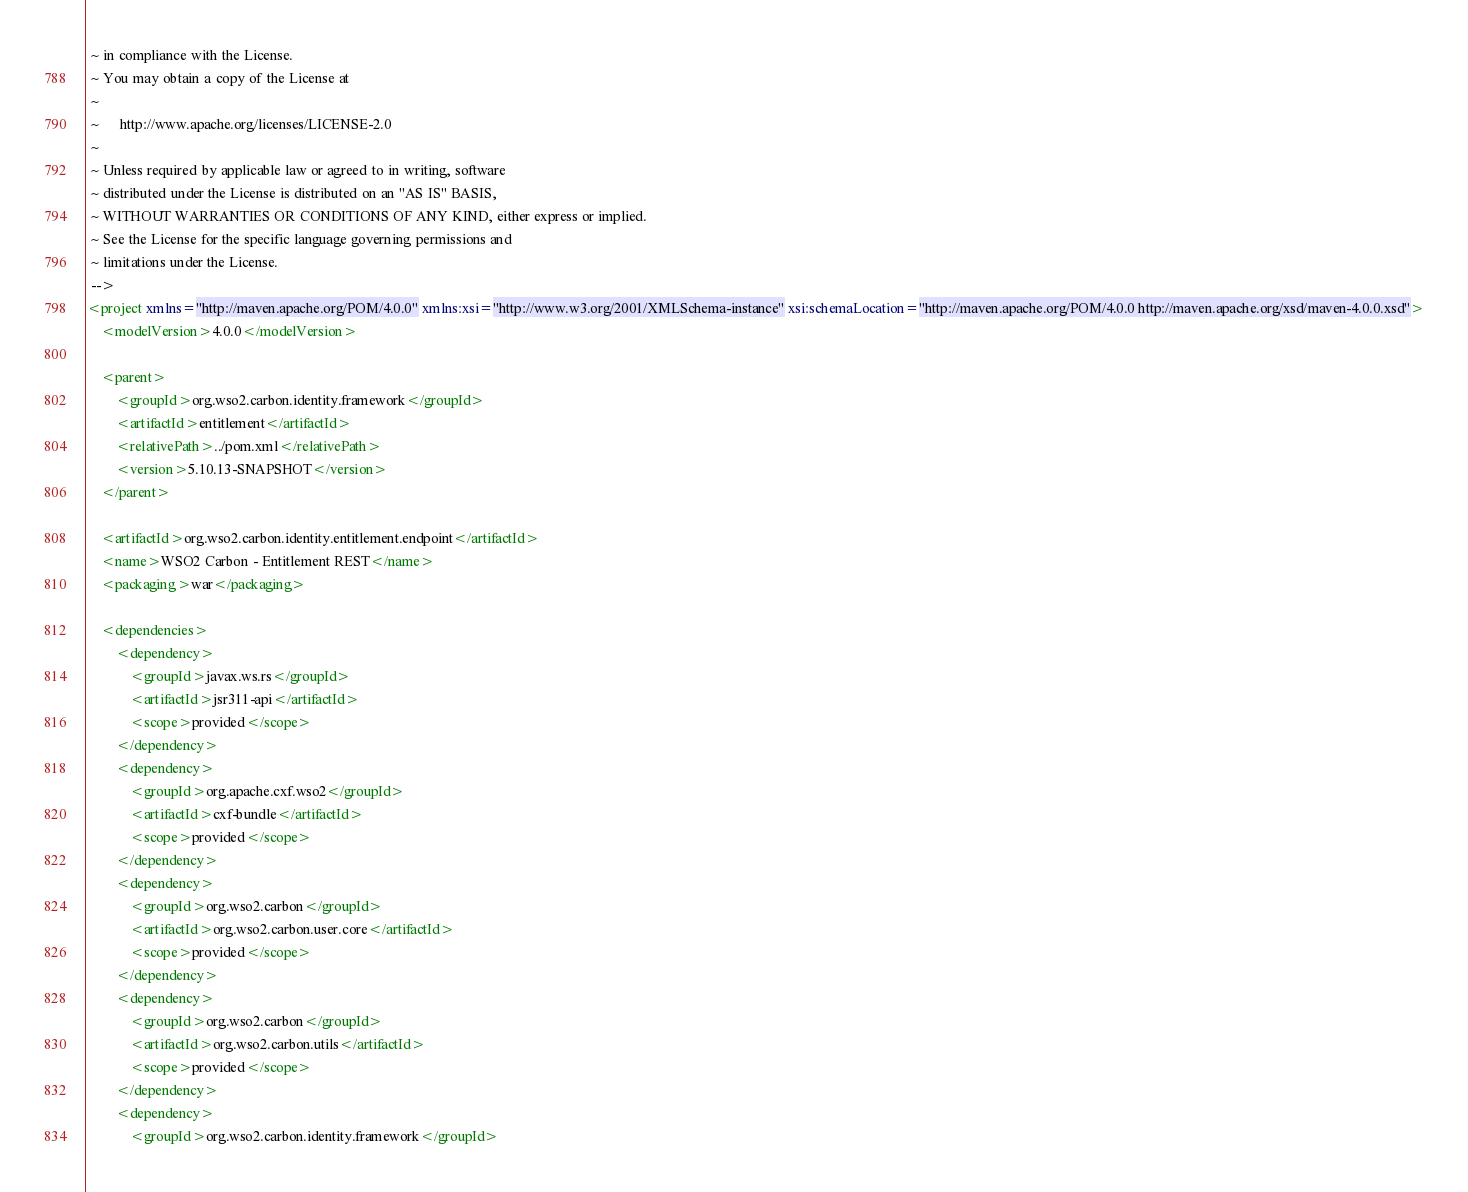Convert code to text. <code><loc_0><loc_0><loc_500><loc_500><_XML_> ~ in compliance with the License.
 ~ You may obtain a copy of the License at
 ~
 ~      http://www.apache.org/licenses/LICENSE-2.0
 ~
 ~ Unless required by applicable law or agreed to in writing, software
 ~ distributed under the License is distributed on an "AS IS" BASIS,
 ~ WITHOUT WARRANTIES OR CONDITIONS OF ANY KIND, either express or implied.
 ~ See the License for the specific language governing permissions and
 ~ limitations under the License.
 -->
<project xmlns="http://maven.apache.org/POM/4.0.0" xmlns:xsi="http://www.w3.org/2001/XMLSchema-instance" xsi:schemaLocation="http://maven.apache.org/POM/4.0.0 http://maven.apache.org/xsd/maven-4.0.0.xsd">
    <modelVersion>4.0.0</modelVersion>

    <parent>
        <groupId>org.wso2.carbon.identity.framework</groupId>
        <artifactId>entitlement</artifactId>
        <relativePath>../pom.xml</relativePath>
        <version>5.10.13-SNAPSHOT</version>
    </parent>

    <artifactId>org.wso2.carbon.identity.entitlement.endpoint</artifactId>
    <name>WSO2 Carbon - Entitlement REST</name>
    <packaging>war</packaging>

    <dependencies>
        <dependency>
            <groupId>javax.ws.rs</groupId>
            <artifactId>jsr311-api</artifactId>
            <scope>provided</scope>
        </dependency>
        <dependency>
            <groupId>org.apache.cxf.wso2</groupId>
            <artifactId>cxf-bundle</artifactId>
            <scope>provided</scope>
        </dependency>
        <dependency>
            <groupId>org.wso2.carbon</groupId>
            <artifactId>org.wso2.carbon.user.core</artifactId>
            <scope>provided</scope>
        </dependency>
        <dependency>
            <groupId>org.wso2.carbon</groupId>
            <artifactId>org.wso2.carbon.utils</artifactId>
            <scope>provided</scope>
        </dependency>
        <dependency>
            <groupId>org.wso2.carbon.identity.framework</groupId></code> 